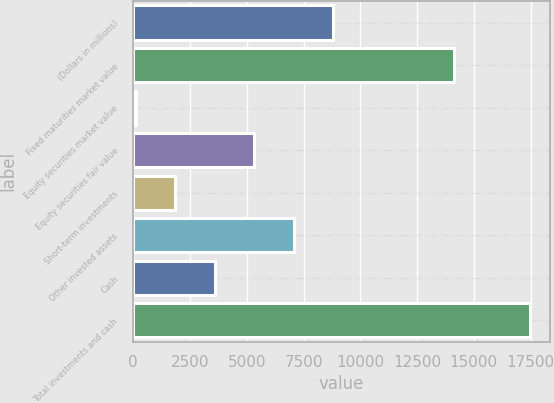<chart> <loc_0><loc_0><loc_500><loc_500><bar_chart><fcel>(Dollars in millions)<fcel>Fixed maturities market value<fcel>Equity securities market value<fcel>Equity securities fair value<fcel>Short-term investments<fcel>Other invested assets<fcel>Cash<fcel>Total investments and cash<nl><fcel>8801.1<fcel>14107.4<fcel>119.1<fcel>5328.3<fcel>1855.5<fcel>7064.7<fcel>3591.9<fcel>17483.1<nl></chart> 